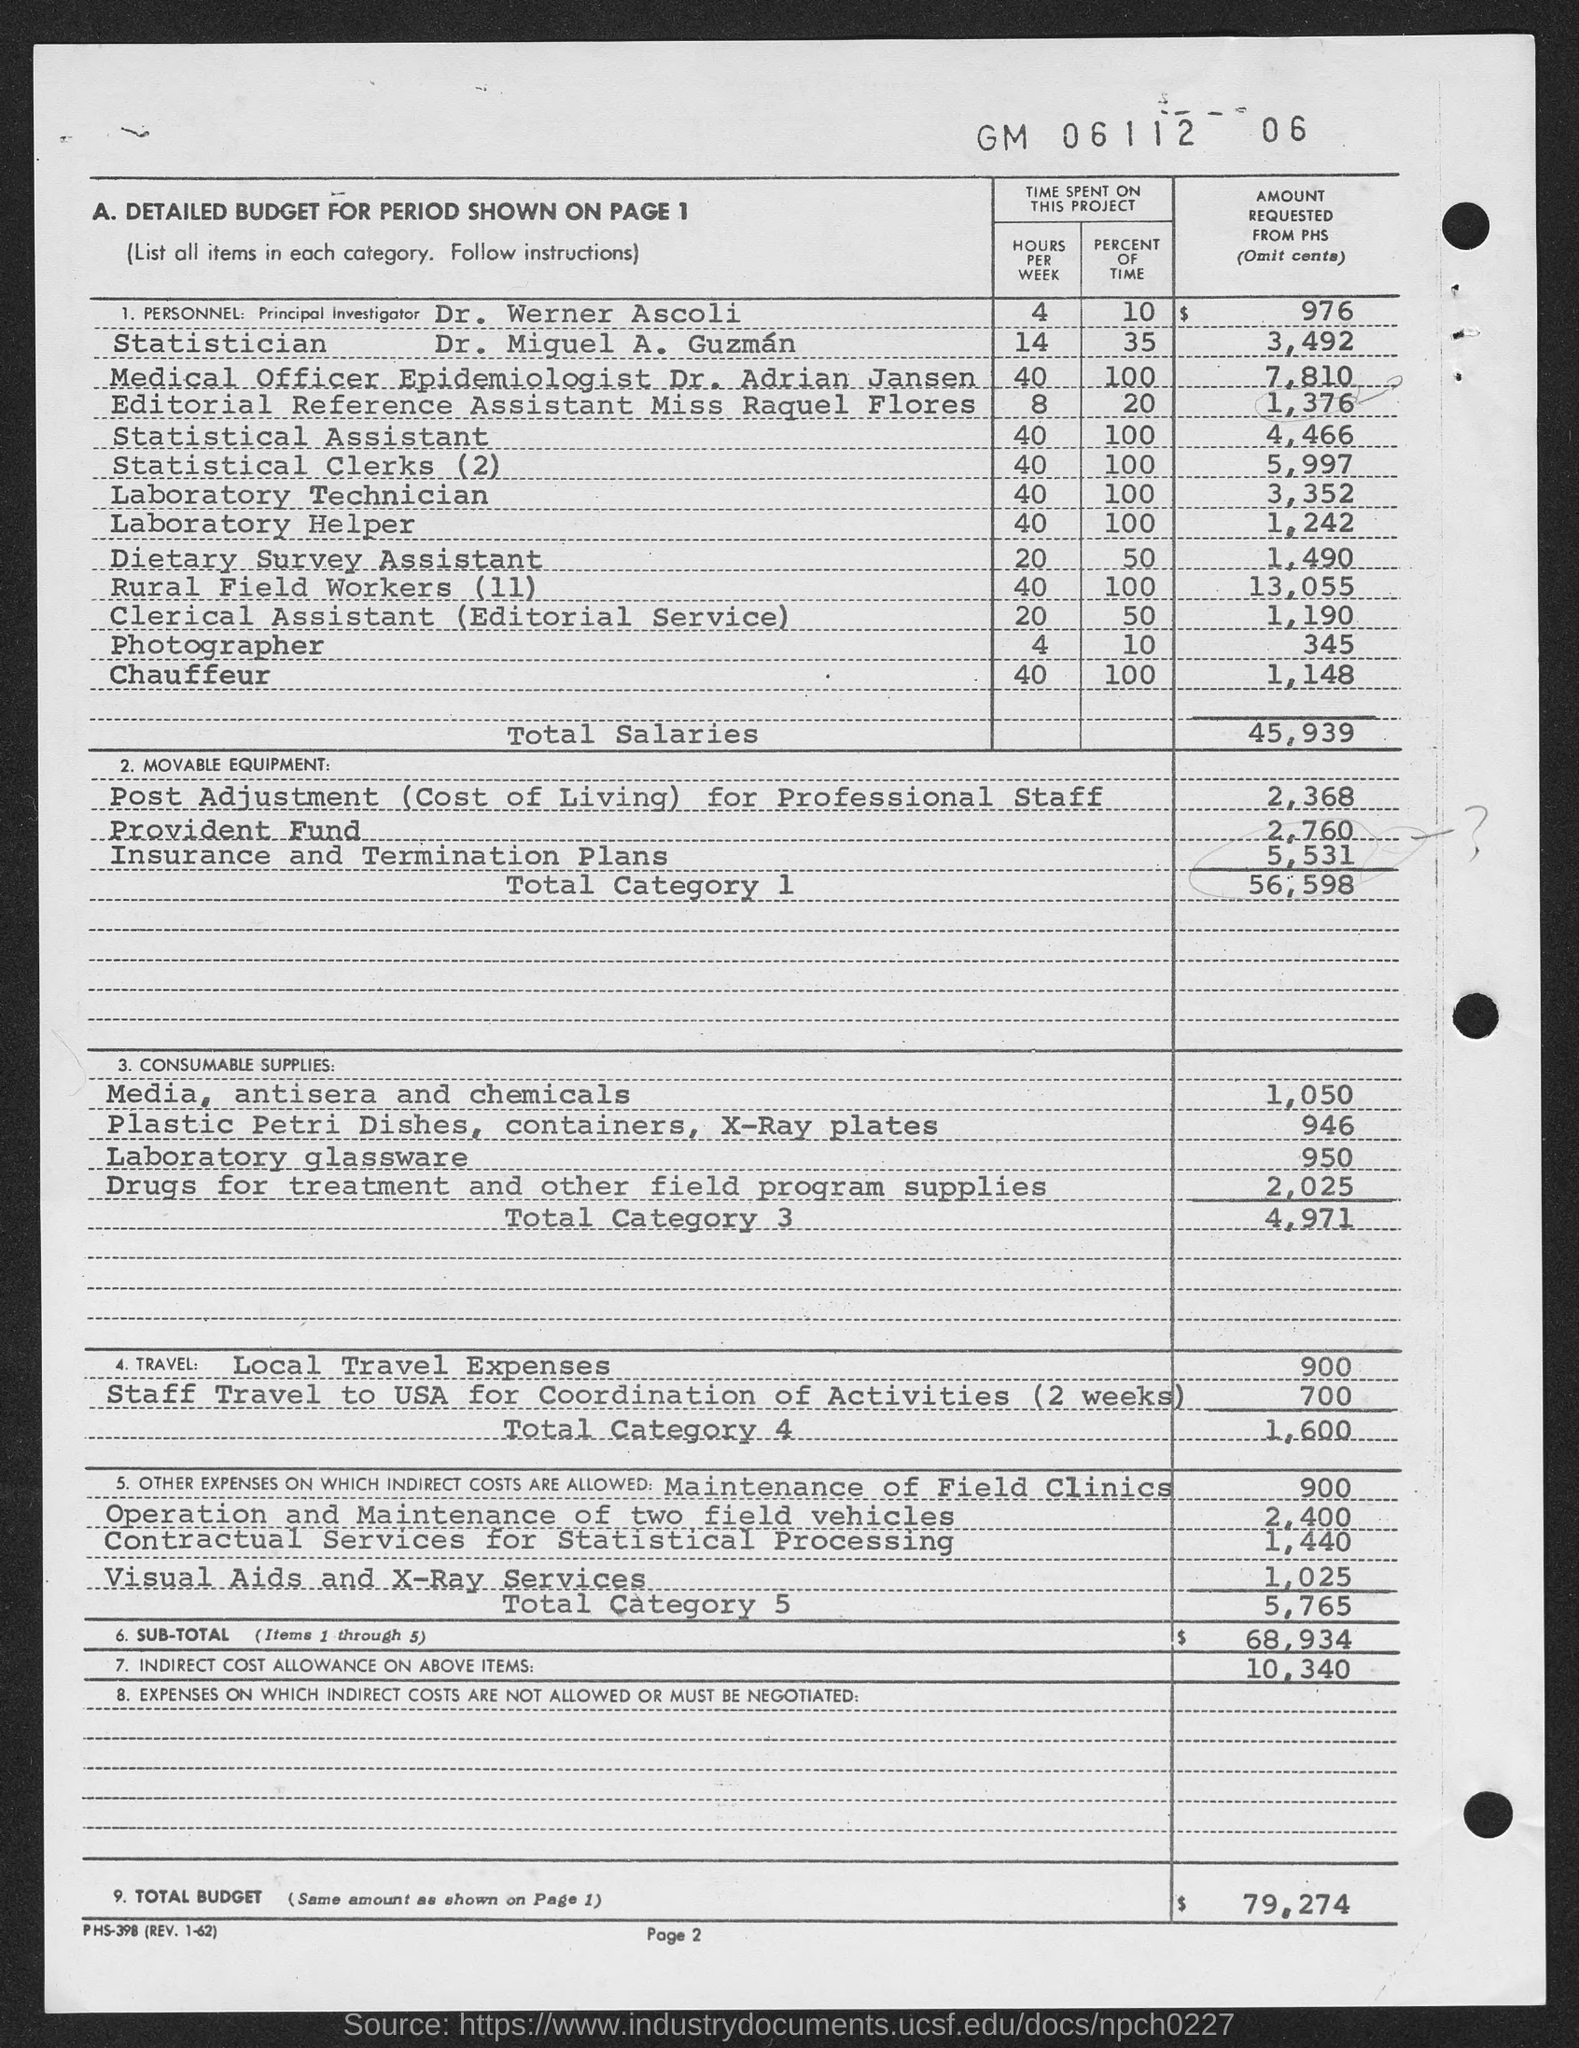List a handful of essential elements in this visual. The principal investigator's name mentioned in the document is Dr. Werner Ascoli. The total budget amount requested from the PHS is $79,274. Approximately 10% of the time spent on this project is contributed by Dr. Werner Ascoli. Miss Raquel Flores spends approximately 8 hours per week on this project. Dr. Adrian Jansen holds the designation of Medical Officer Epidemiologist. 